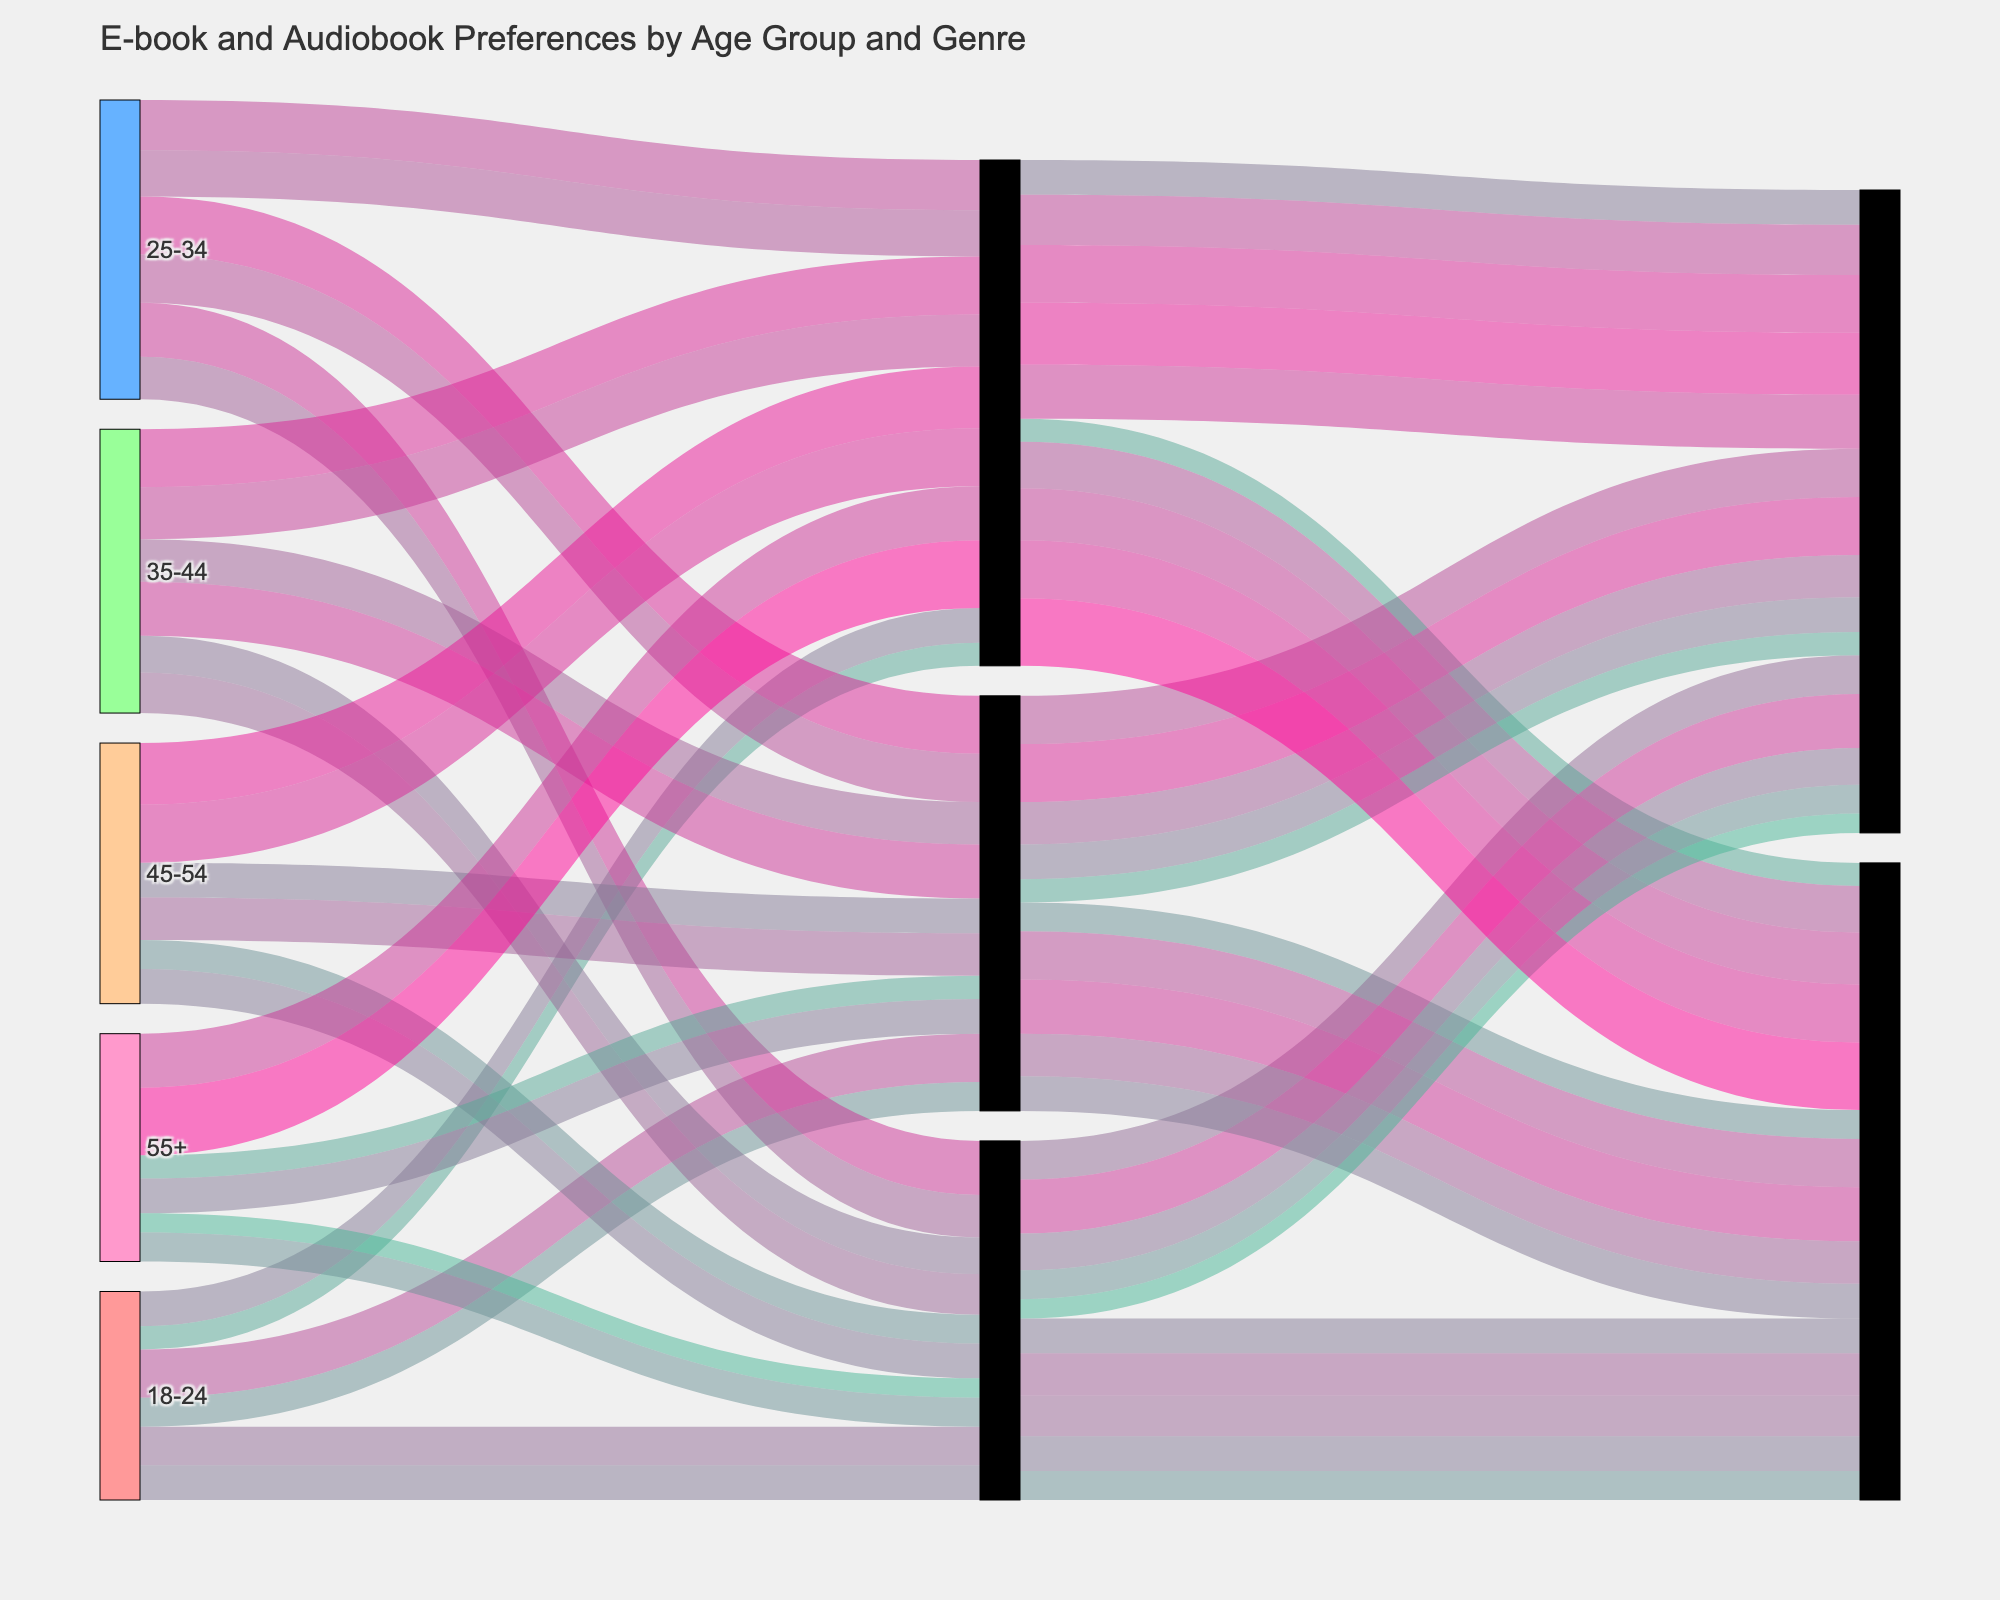Which age group has the highest preference for e-books in the Romance genre? To find the age group with the highest preference for Romance e-books, look at the links that connect the "Romance" node to each age group's "E-book" node, and compare the values. The 25-34 age group has the highest value (300).
Answer: 25-34 What is the total number of e-book preferences for the 18-24 age group across all genres? To get the total number of e-book preferences for the 18-24 age group, sum the values of e-books in all genres for this age group: 250 (Romance) + 200 (Science Fiction) + 180 (Mystery) = 630.
Answer: 630 Do older age groups (45+) prefer Mystery over other genres in comparison to younger age groups (below 45)? Sum up the Mystery preferences (both e-books and audiobooks) for the older age groups (45+): 
- 45-54: 320 (e-books) + 300 (audiobooks) = 620 
- 55+: 280 (e-books) + 350 (audiobooks) = 630
Now compare it with the total for younger age groups (below 45): 
- 18-24: 180 (e-books) + 120 (audiobooks) = 300 
- 25-34: 260 (e-books) + 240 (audiobooks) = 500 
- 35-44: 300 (e-books) + 270 (audiobooks) = 570
The total for older age groups (1250) is higher than for younger age groups (1370), indicating a higher overall preference for Mystery among older age groups.
Answer: Yes Which preference type (e-book or audiobook) dominates the Mystery genre across all age groups? Sum up the values for both e-books and audiobooks in the Mystery genre across all age groups: 
- E-books: 180 + 260 + 300 + 320 + 280 = 1340 
- Audiobooks: 120 + 240 + 270 + 300 + 350 = 1280
E-books have a higher total value (1340).
Answer: E-books How does the preference for Science Fiction audiobooks compare between the 18-24 and the 55+ age groups? Compare the values of Science Fiction audiobooks directly for these age groups:
- 18-24: 180
- 55+: 150
The 18-24 age group has a higher preference (180 vs 150).
Answer: 18-24 What is the average preference for Romance e-books across all age groups? Calculate the average by summing the Romance e-book preferences and dividing by the number of age groups: 
120 + 180 + 220 + 300 + 250 = 1070 
Average = 1070 / 5 = 214
Answer: 214 